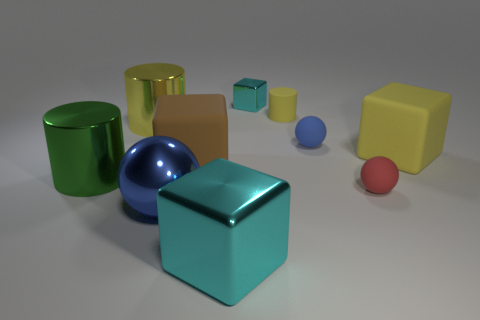Subtract all yellow matte blocks. How many blocks are left? 3 Subtract all yellow cylinders. How many cylinders are left? 1 Subtract all cylinders. How many objects are left? 7 Add 6 blue blocks. How many blue blocks exist? 6 Subtract 2 blue balls. How many objects are left? 8 Subtract 2 balls. How many balls are left? 1 Subtract all yellow cubes. Subtract all red spheres. How many cubes are left? 3 Subtract all red spheres. How many red cylinders are left? 0 Subtract all big blue rubber cubes. Subtract all red rubber balls. How many objects are left? 9 Add 3 tiny metallic cubes. How many tiny metallic cubes are left? 4 